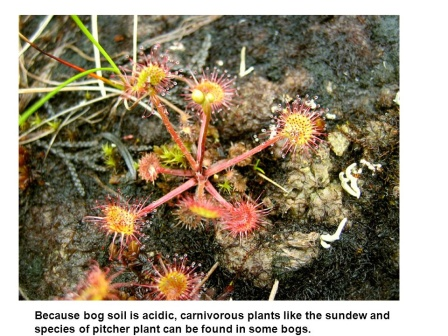If these plants were used in a fictional story, what kind of plot twist involving them would be captivating? Imagine a story where a group of botanists ventures into the bog to study the carnivorous plants. They discover that these plants are not just passive insect-eaters but are actively communicating with the environment and each other through subtle chemical signals. As the story unfolds, it becomes apparent that the plants are sentient, formulating a plan to defend their bog from an impending human development project. The botanists find themselves caught in a thrilling adventure, trying to understand and eventually protect the intelligent plants. In what other ways might carnivorous plants adapt if introduced to a different environment? If carnivorous plants were introduced to a different environment, they might develop new adaptations to suit their surroundings. In a drier environment, for instance, they might evolve to store water more effectively or spread their seeds further to find suitable moist areas. In a denser forest, they could develop taller structures to capture more sunlight and perhaps even become more aggressive in their trapping mechanisms to outcompete other plants for insect prey. The adaptability of carnivorous plants highlights their incredible evolutionary journey. 